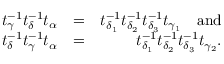Convert formula to latex. <formula><loc_0><loc_0><loc_500><loc_500>\begin{array} { r l r } { t _ { \gamma } ^ { - 1 } t _ { \delta } ^ { - 1 } t _ { \alpha } } & { = } & { t _ { \delta _ { 1 } } ^ { - 1 } t _ { \delta _ { 2 } } ^ { - 1 } t _ { \delta _ { 3 } } ^ { - 1 } t _ { \gamma _ { 1 } } \quad a n d } \\ { t _ { \delta } ^ { - 1 } t _ { \gamma } ^ { - 1 } t _ { \alpha } } & { = } & { t _ { \delta _ { 1 } } ^ { - 1 } t _ { \delta _ { 2 } } ^ { - 1 } t _ { \delta _ { 3 } } ^ { - 1 } t _ { \gamma _ { 2 } } . } \end{array}</formula> 